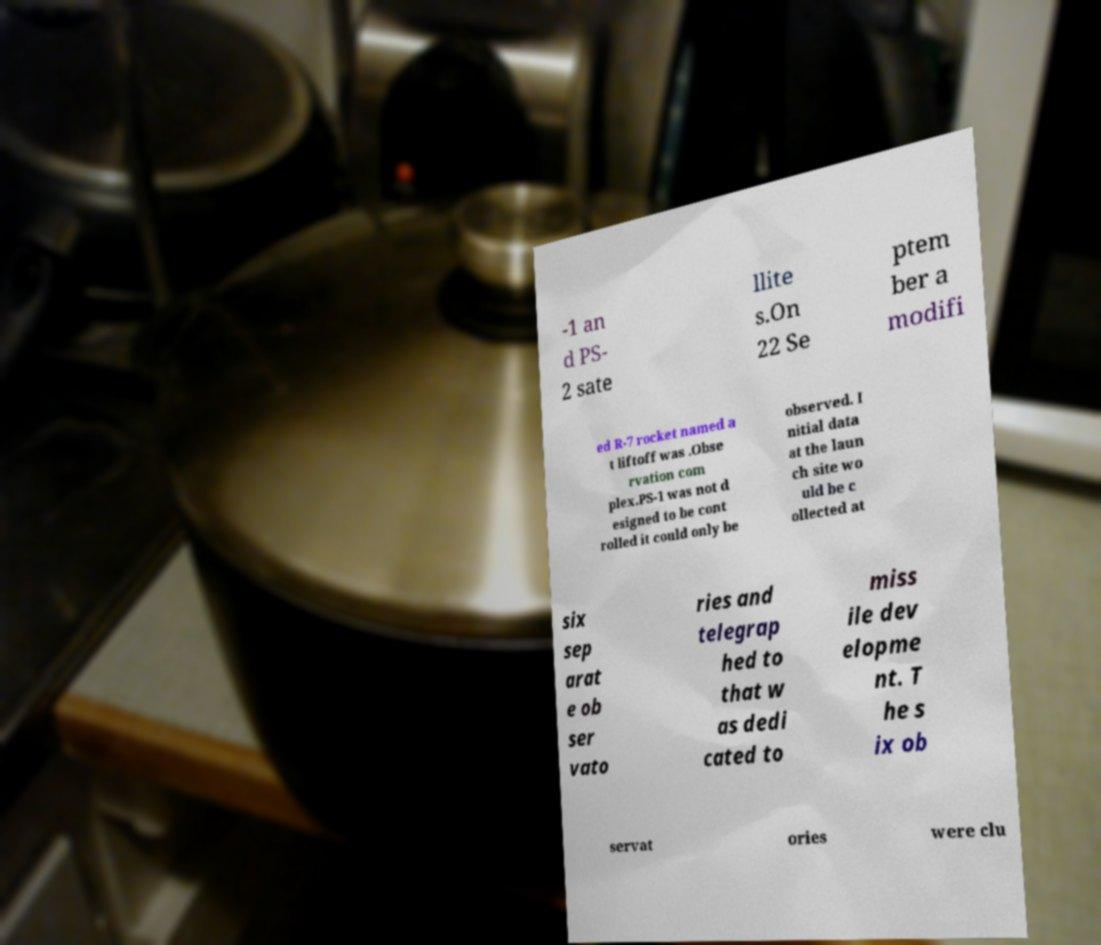Can you read and provide the text displayed in the image?This photo seems to have some interesting text. Can you extract and type it out for me? -1 an d PS- 2 sate llite s.On 22 Se ptem ber a modifi ed R-7 rocket named a t liftoff was .Obse rvation com plex.PS-1 was not d esigned to be cont rolled it could only be observed. I nitial data at the laun ch site wo uld be c ollected at six sep arat e ob ser vato ries and telegrap hed to that w as dedi cated to miss ile dev elopme nt. T he s ix ob servat ories were clu 